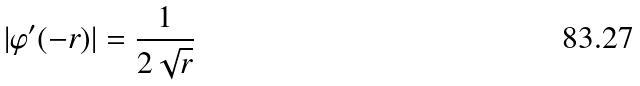Convert formula to latex. <formula><loc_0><loc_0><loc_500><loc_500>| \varphi ^ { \prime } ( - r ) | = \frac { 1 } { 2 \sqrt { r } }</formula> 